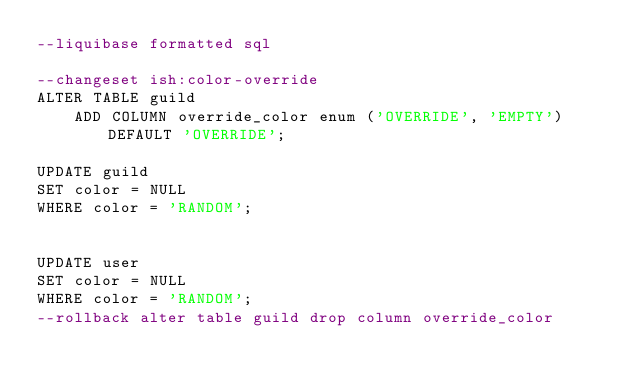<code> <loc_0><loc_0><loc_500><loc_500><_SQL_>--liquibase formatted sql

--changeset ish:color-override
ALTER TABLE guild
    ADD COLUMN override_color enum ('OVERRIDE', 'EMPTY') DEFAULT 'OVERRIDE';

UPDATE guild
SET color = NULL
WHERE color = 'RANDOM';


UPDATE user
SET color = NULL
WHERE color = 'RANDOM';
--rollback alter table guild drop column override_color
</code> 